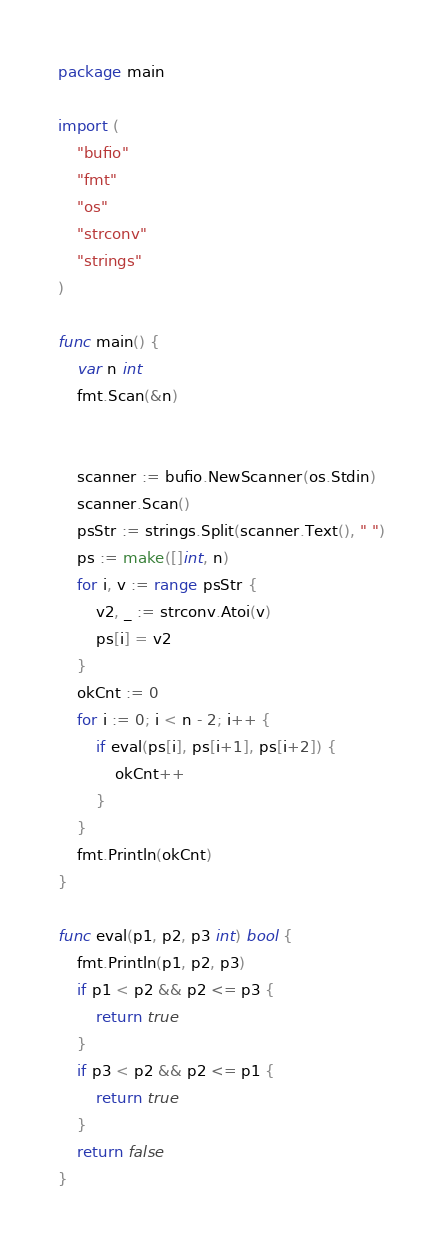<code> <loc_0><loc_0><loc_500><loc_500><_Go_>package main

import (
	"bufio"
	"fmt"
	"os"
	"strconv"
	"strings"
)

func main() {
	var n int
	fmt.Scan(&n)


	scanner := bufio.NewScanner(os.Stdin)
	scanner.Scan()
	psStr := strings.Split(scanner.Text(), " ")
	ps := make([]int, n)
	for i, v := range psStr {
		v2, _ := strconv.Atoi(v)
		ps[i] = v2
	}
	okCnt := 0
	for i := 0; i < n - 2; i++ {
		if eval(ps[i], ps[i+1], ps[i+2]) {
			okCnt++
		}
	}
	fmt.Println(okCnt)
}

func eval(p1, p2, p3 int) bool {
	fmt.Println(p1, p2, p3)
	if p1 < p2 && p2 <= p3 {
		return true
	}
	if p3 < p2 && p2 <= p1 {
		return true
	}
	return false
}</code> 